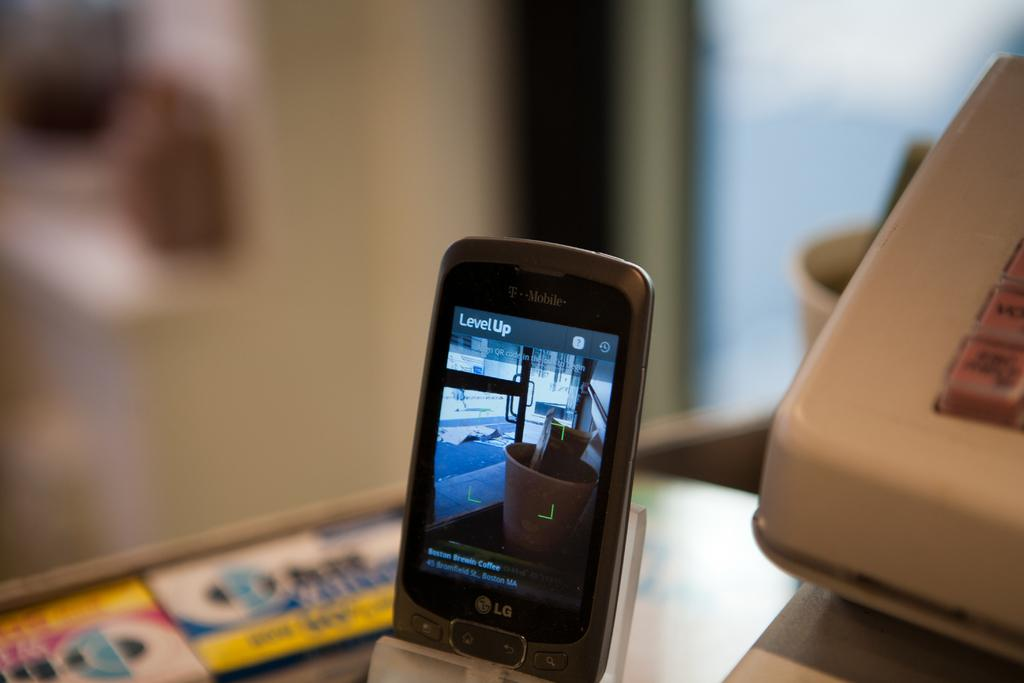<image>
Write a terse but informative summary of the picture. a phone that says level up at the top of it 